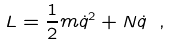Convert formula to latex. <formula><loc_0><loc_0><loc_500><loc_500>L = \frac { 1 } { 2 } m \dot { q } ^ { 2 } + N \dot { q } \ ,</formula> 